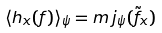Convert formula to latex. <formula><loc_0><loc_0><loc_500><loc_500>\langle h _ { x } ( f ) \rangle _ { \psi } = m \, j _ { \psi } ( \tilde { f } _ { x } )</formula> 